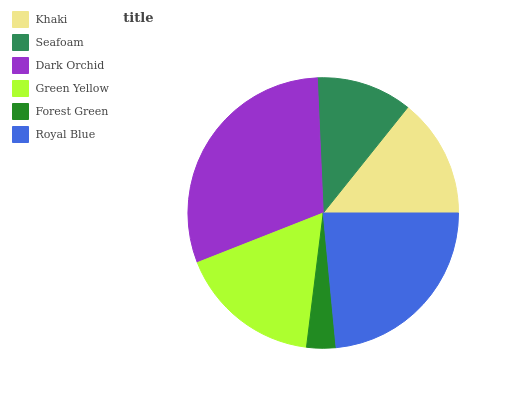Is Forest Green the minimum?
Answer yes or no. Yes. Is Dark Orchid the maximum?
Answer yes or no. Yes. Is Seafoam the minimum?
Answer yes or no. No. Is Seafoam the maximum?
Answer yes or no. No. Is Khaki greater than Seafoam?
Answer yes or no. Yes. Is Seafoam less than Khaki?
Answer yes or no. Yes. Is Seafoam greater than Khaki?
Answer yes or no. No. Is Khaki less than Seafoam?
Answer yes or no. No. Is Green Yellow the high median?
Answer yes or no. Yes. Is Khaki the low median?
Answer yes or no. Yes. Is Khaki the high median?
Answer yes or no. No. Is Seafoam the low median?
Answer yes or no. No. 